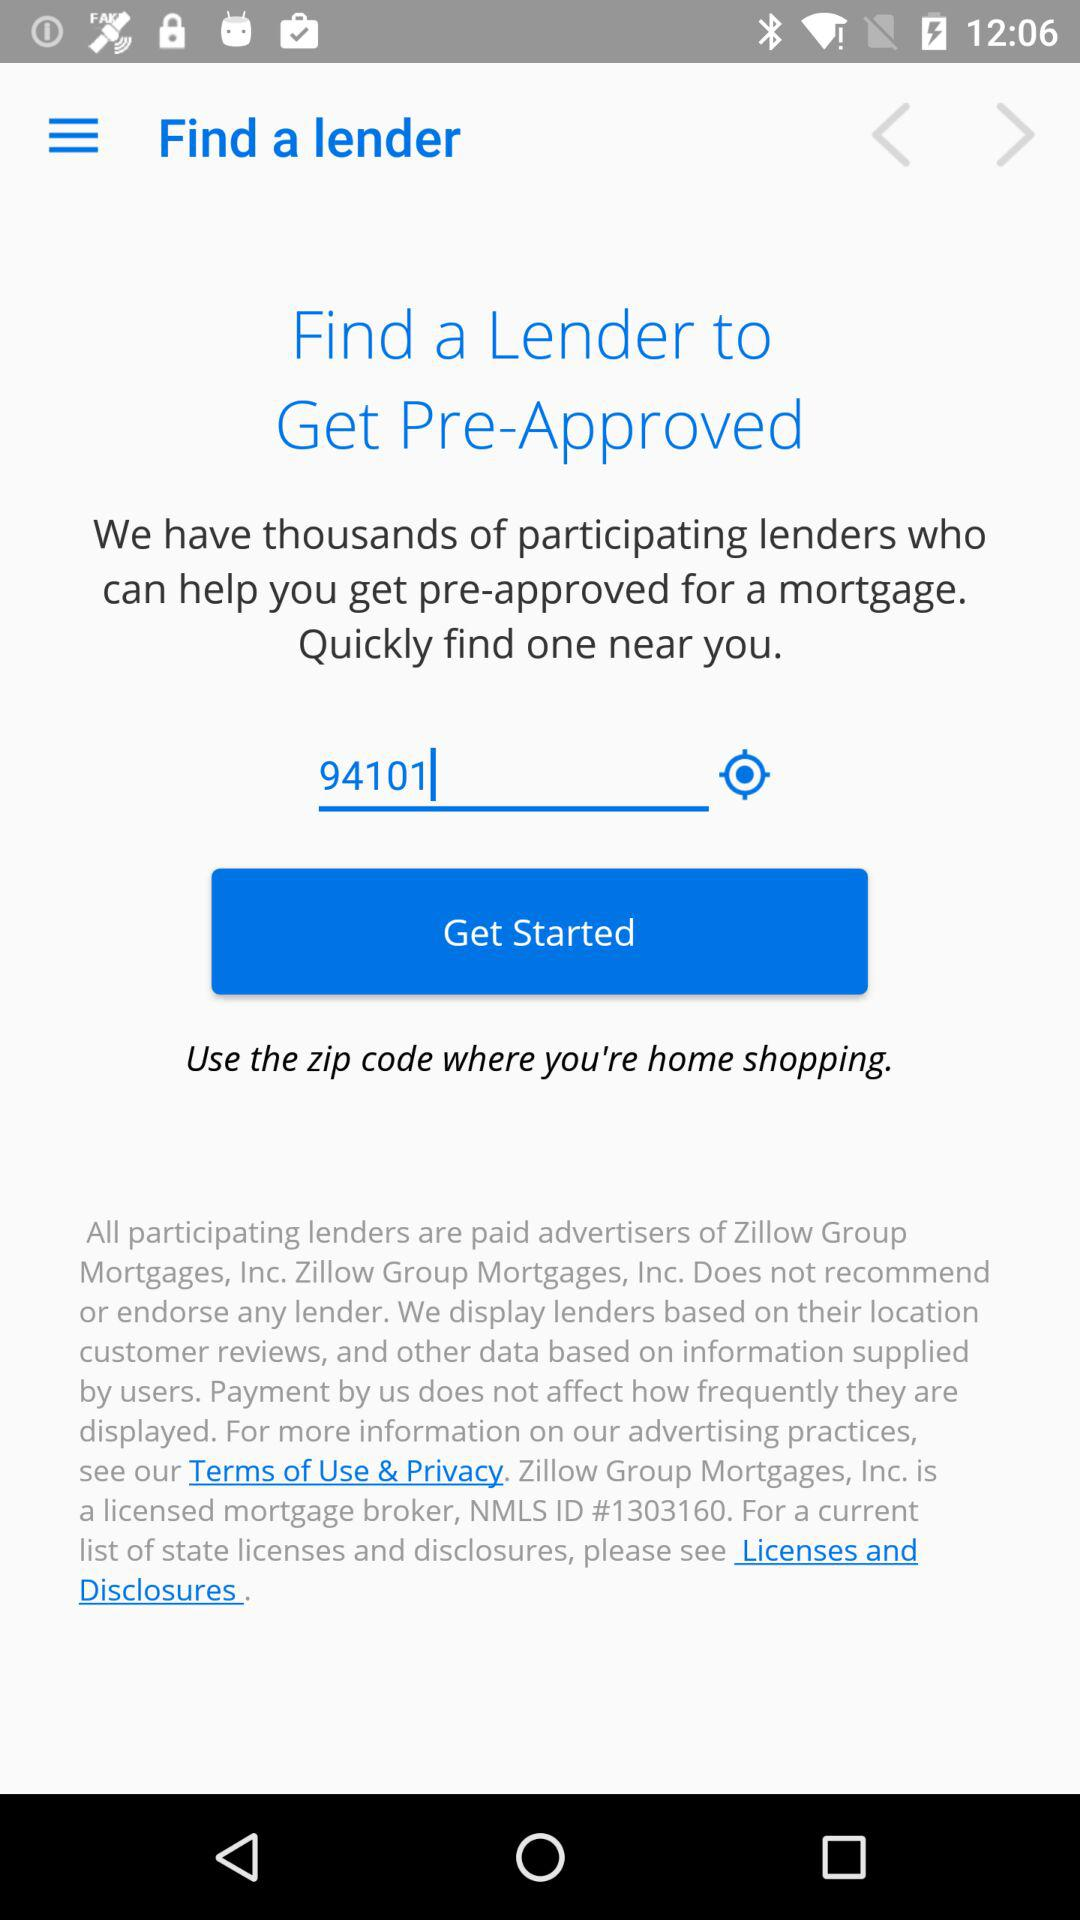What is the entered zip code? The entered zip code is 94101. 